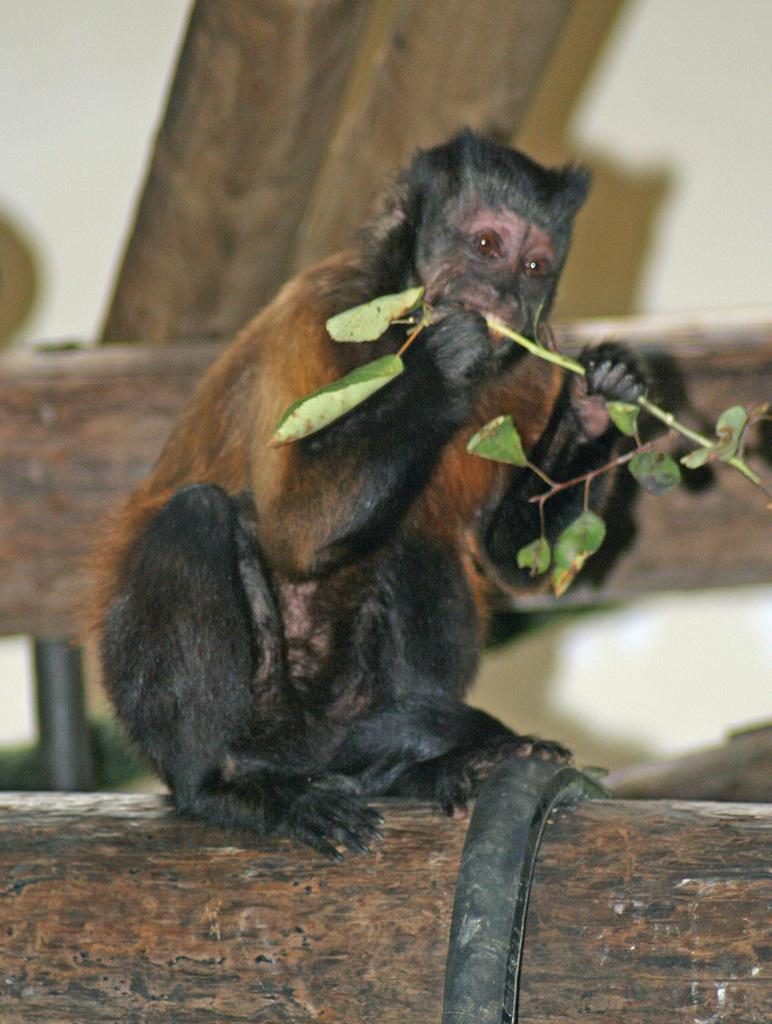What animal is present in the image? There is a monkey in the image. What is the monkey sitting on? The monkey is sitting on a wooden log. What is the monkey doing in the image? The monkey is eating leaves. Can you describe the background of the image? The background of the monkey is blurred. How many trees are visible in the image? There are no trees visible in the image; it only features a monkey sitting on a wooden log. What type of exchange is taking place between the monkey and the deer in the image? There is no deer present in the image, and therefore no exchange can be observed. 